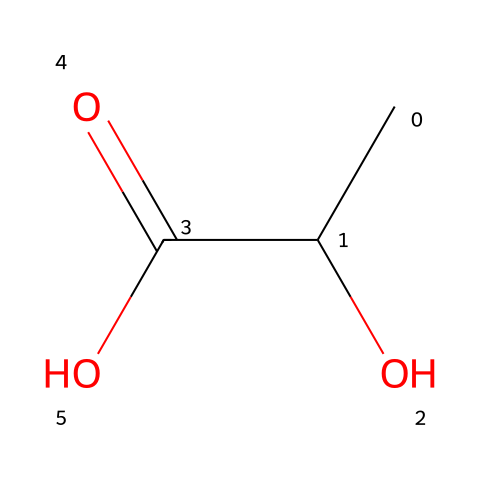What is the molecular formula of lactic acid? The SMILES representation can be interpreted to count the number of each type of atom. From CC(O)C(=O)O, we identify 3 carbons (C), 6 hydrogens (H), and 3 oxygens (O). Therefore, the molecular formula is derived directly from counting these atoms.
Answer: C3H6O3 How many stereocenters does lactic acid have? A stereocenter is a carbon atom bonded to four different groups. Looking at the structure from the SMILES, we see only one carbon atom (the one connected to the hydroxyl group, the carboxylic acid, and the two remaining carbon and hydrogen groups) has four unique attachments. Thus, there is one stereocenter in lactic acid.
Answer: 1 What functional groups are present in lactic acid? Analyzing the structure, we observe a hydroxyl group (-OH) and a carboxylic acid group (-COOH). These functional groups are characteristic of alcohols and acids respectively. Therefore, the presence of these two distinct groups is noted.
Answer: Hydroxyl and Carboxylic Acid What is the degree of saturation of lactic acid? Degree of saturation refers to the number of double bonds or rings in a compound. In this case, we have one C=C double bond in the carbon chain and also a carbonyl group (C=O), indicating two sites of unsaturation. Therefore, the degree of saturation is calculated as one double bond and one ring.
Answer: 2 Is lactic acid an organic acid or inorganic acid? Lactic acid contains carbon atoms in its structure, as seen in the SMILES, indicating it has organic properties. Organic acids typically have a carbon backbone, which lactic acid possesses, categorizing it clearly as an organic acid.
Answer: Organic Acid How many hydrogen atoms are directly attached to the first carbon in lactic acid? Reviewing the structure, the first carbon bonded to the hydroxyl group (C-OH) is connected to one hydroxyl group and one carbon atom. Therefore, it must have one hydrogen attached to complete the tetravalency of carbon. Thus, the number of hydrogen atoms directly linked to the first carbon can be counted visually.
Answer: 1 